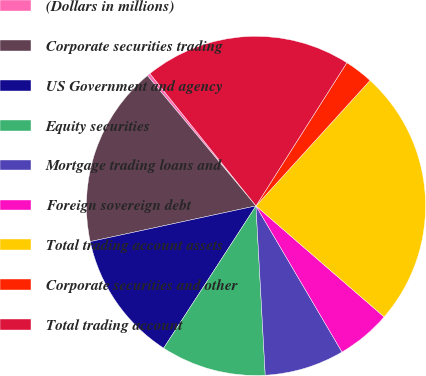Convert chart to OTSL. <chart><loc_0><loc_0><loc_500><loc_500><pie_chart><fcel>(Dollars in millions)<fcel>Corporate securities trading<fcel>US Government and agency<fcel>Equity securities<fcel>Mortgage trading loans and<fcel>Foreign sovereign debt<fcel>Total trading account assets<fcel>Corporate securities and other<fcel>Total trading account<nl><fcel>0.3%<fcel>17.32%<fcel>12.46%<fcel>10.03%<fcel>7.6%<fcel>5.17%<fcel>24.62%<fcel>2.74%<fcel>19.76%<nl></chart> 